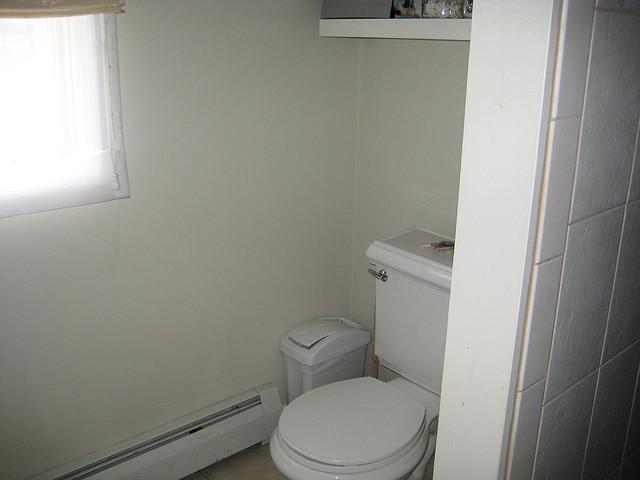Is there much privacy at this toilet?
Give a very brief answer. No. What color is the room?
Keep it brief. White. What color are the bathroom walls?
Keep it brief. White. Is the window open?
Give a very brief answer. No. 